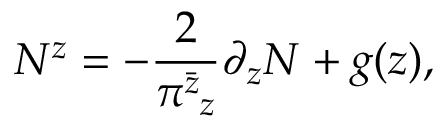Convert formula to latex. <formula><loc_0><loc_0><loc_500><loc_500>N ^ { z } = - \frac { 2 } { \pi _ { z } ^ { \bar { z } } } \partial _ { z } N + g ( z ) ,</formula> 